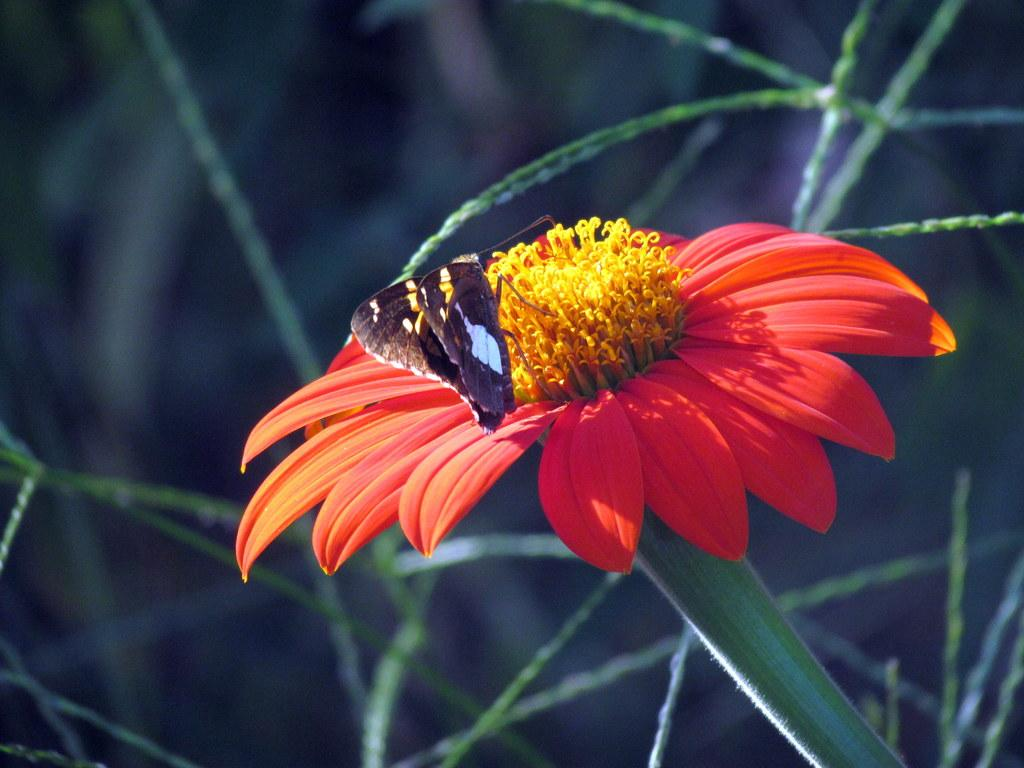What is the main subject of the image? There is a butterfly on a flower in the image. What can be seen in the background of the image? There is grass in the background of the image. How would you describe the quality of the image? The image is blurred. Can you tell me how many squirrels are playing in the air in the image? There are no squirrels present in the image, and they are not playing in the air. What type of care is being provided to the butterfly in the image? There is no indication in the image that the butterfly is receiving any care. 